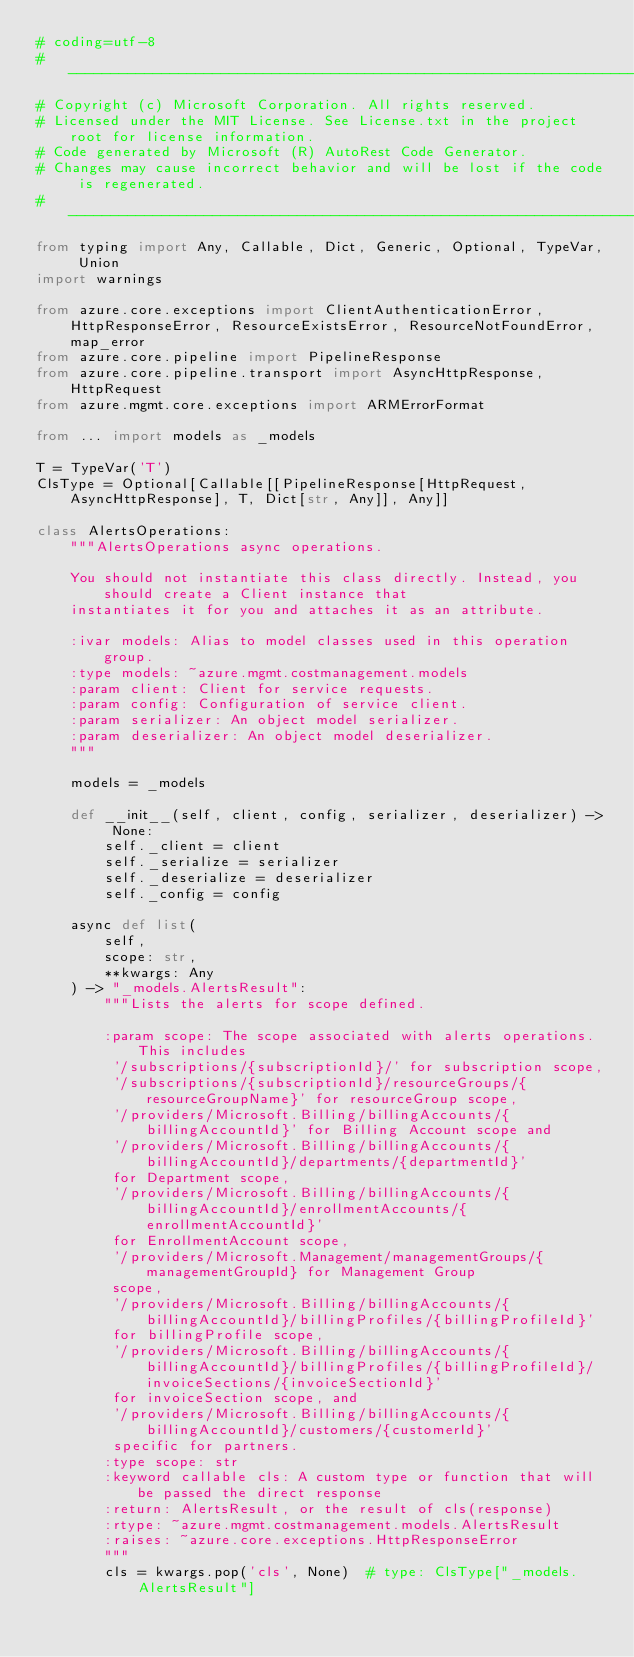Convert code to text. <code><loc_0><loc_0><loc_500><loc_500><_Python_># coding=utf-8
# --------------------------------------------------------------------------
# Copyright (c) Microsoft Corporation. All rights reserved.
# Licensed under the MIT License. See License.txt in the project root for license information.
# Code generated by Microsoft (R) AutoRest Code Generator.
# Changes may cause incorrect behavior and will be lost if the code is regenerated.
# --------------------------------------------------------------------------
from typing import Any, Callable, Dict, Generic, Optional, TypeVar, Union
import warnings

from azure.core.exceptions import ClientAuthenticationError, HttpResponseError, ResourceExistsError, ResourceNotFoundError, map_error
from azure.core.pipeline import PipelineResponse
from azure.core.pipeline.transport import AsyncHttpResponse, HttpRequest
from azure.mgmt.core.exceptions import ARMErrorFormat

from ... import models as _models

T = TypeVar('T')
ClsType = Optional[Callable[[PipelineResponse[HttpRequest, AsyncHttpResponse], T, Dict[str, Any]], Any]]

class AlertsOperations:
    """AlertsOperations async operations.

    You should not instantiate this class directly. Instead, you should create a Client instance that
    instantiates it for you and attaches it as an attribute.

    :ivar models: Alias to model classes used in this operation group.
    :type models: ~azure.mgmt.costmanagement.models
    :param client: Client for service requests.
    :param config: Configuration of service client.
    :param serializer: An object model serializer.
    :param deserializer: An object model deserializer.
    """

    models = _models

    def __init__(self, client, config, serializer, deserializer) -> None:
        self._client = client
        self._serialize = serializer
        self._deserialize = deserializer
        self._config = config

    async def list(
        self,
        scope: str,
        **kwargs: Any
    ) -> "_models.AlertsResult":
        """Lists the alerts for scope defined.

        :param scope: The scope associated with alerts operations. This includes
         '/subscriptions/{subscriptionId}/' for subscription scope,
         '/subscriptions/{subscriptionId}/resourceGroups/{resourceGroupName}' for resourceGroup scope,
         '/providers/Microsoft.Billing/billingAccounts/{billingAccountId}' for Billing Account scope and
         '/providers/Microsoft.Billing/billingAccounts/{billingAccountId}/departments/{departmentId}'
         for Department scope,
         '/providers/Microsoft.Billing/billingAccounts/{billingAccountId}/enrollmentAccounts/{enrollmentAccountId}'
         for EnrollmentAccount scope,
         '/providers/Microsoft.Management/managementGroups/{managementGroupId} for Management Group
         scope,
         '/providers/Microsoft.Billing/billingAccounts/{billingAccountId}/billingProfiles/{billingProfileId}'
         for billingProfile scope,
         '/providers/Microsoft.Billing/billingAccounts/{billingAccountId}/billingProfiles/{billingProfileId}/invoiceSections/{invoiceSectionId}'
         for invoiceSection scope, and
         '/providers/Microsoft.Billing/billingAccounts/{billingAccountId}/customers/{customerId}'
         specific for partners.
        :type scope: str
        :keyword callable cls: A custom type or function that will be passed the direct response
        :return: AlertsResult, or the result of cls(response)
        :rtype: ~azure.mgmt.costmanagement.models.AlertsResult
        :raises: ~azure.core.exceptions.HttpResponseError
        """
        cls = kwargs.pop('cls', None)  # type: ClsType["_models.AlertsResult"]</code> 